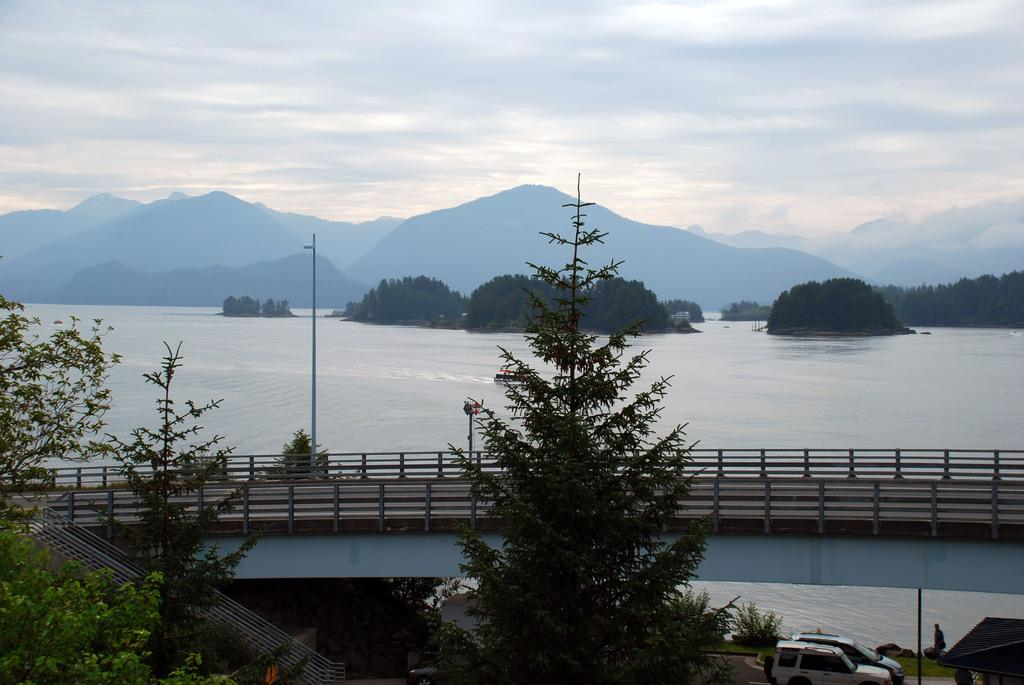What type of natural elements can be seen in the image? There are trees and mountains in the image. What man-made structure is present in the image? There is a bridge in the image. What mode of transportation can be seen in the image? There are vehicles in the image. What body of water is visible in the image? There is water in the image. What is the color of the sky in the image? The sky is white and blue in color. Where is the vase located in the image? There is no vase present in the image. What type of insect can be seen crawling on the bridge in the image? There are no insects, including beetles, visible in the image. 